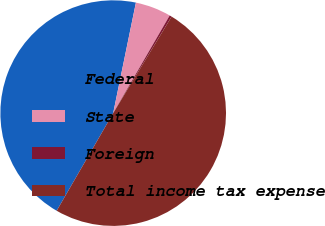Convert chart to OTSL. <chart><loc_0><loc_0><loc_500><loc_500><pie_chart><fcel>Federal<fcel>State<fcel>Foreign<fcel>Total income tax expense<nl><fcel>44.88%<fcel>5.12%<fcel>0.31%<fcel>49.69%<nl></chart> 